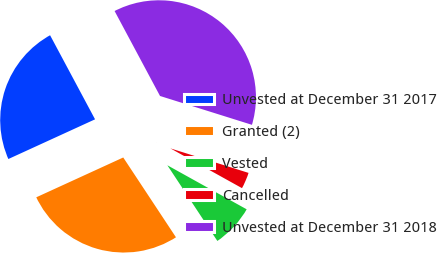<chart> <loc_0><loc_0><loc_500><loc_500><pie_chart><fcel>Unvested at December 31 2017<fcel>Granted (2)<fcel>Vested<fcel>Cancelled<fcel>Unvested at December 31 2018<nl><fcel>24.02%<fcel>27.46%<fcel>7.64%<fcel>3.23%<fcel>37.66%<nl></chart> 